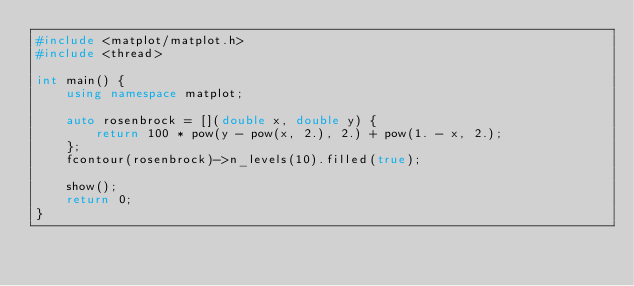Convert code to text. <code><loc_0><loc_0><loc_500><loc_500><_C++_>#include <matplot/matplot.h>
#include <thread>

int main() {
    using namespace matplot;

    auto rosenbrock = [](double x, double y) {
        return 100 * pow(y - pow(x, 2.), 2.) + pow(1. - x, 2.);
    };
    fcontour(rosenbrock)->n_levels(10).filled(true);

    show();
    return 0;
}</code> 